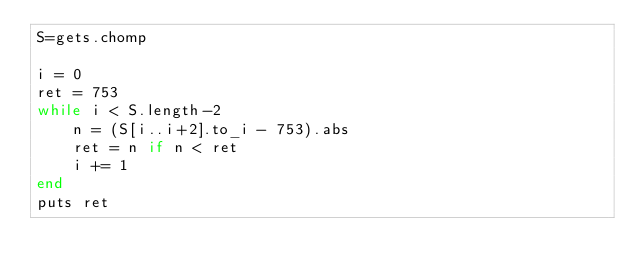Convert code to text. <code><loc_0><loc_0><loc_500><loc_500><_Ruby_>S=gets.chomp

i = 0
ret = 753
while i < S.length-2
    n = (S[i..i+2].to_i - 753).abs
    ret = n if n < ret
    i += 1
end
puts ret
</code> 